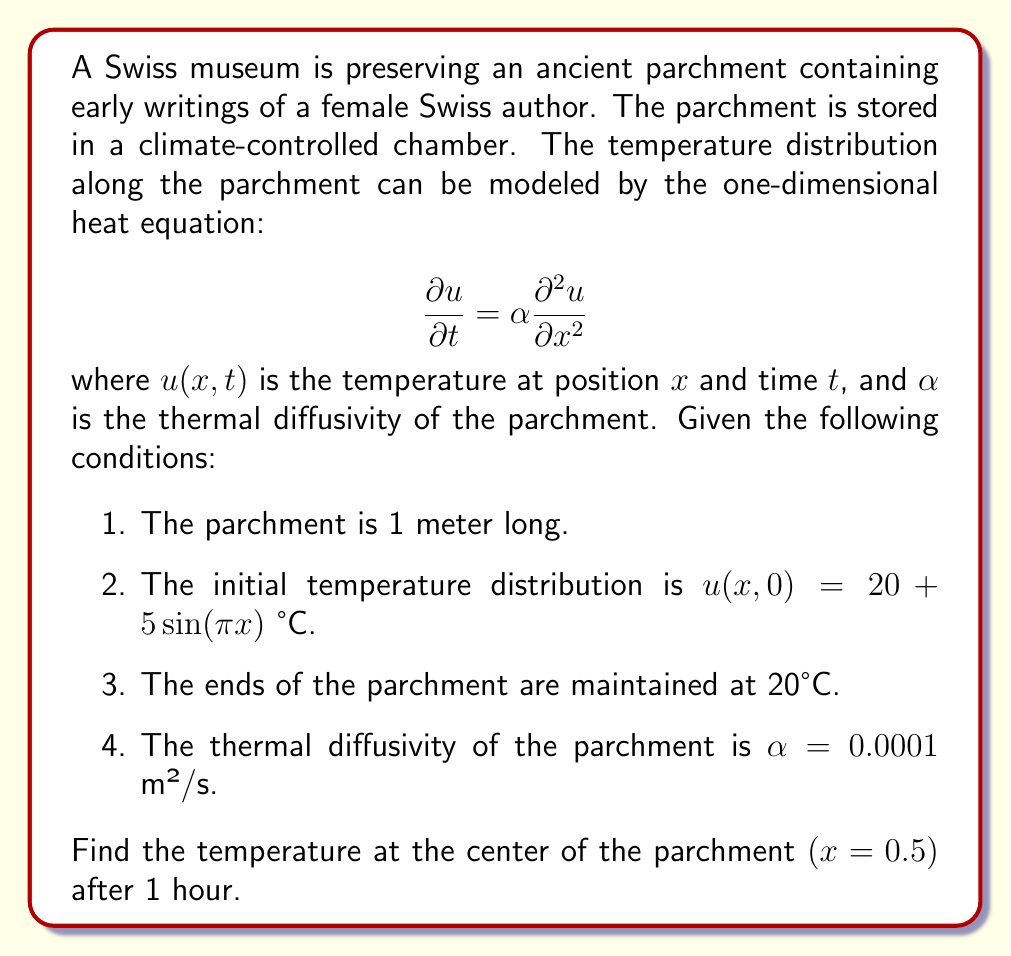Teach me how to tackle this problem. To solve this problem, we'll use the method of separation of variables for the heat equation.

Step 1: The general solution to the heat equation with the given boundary conditions is:

$$u(x,t) = 20 + \sum_{n=1}^{\infty} B_n \sin(n\pi x) e^{-\alpha n^2\pi^2 t}$$

Step 2: Given the initial condition, we only need to consider $n=1$:

$$u(x,0) = 20 + 5\sin(\pi x)$$

So, $B_1 = 5$ and $B_n = 0$ for $n > 1$.

Step 3: Our solution simplifies to:

$$u(x,t) = 20 + 5\sin(\pi x) e^{-\alpha \pi^2 t}$$

Step 4: Calculate the temperature at $x = 0.5$ and $t = 3600$ seconds (1 hour):

$$u(0.5, 3600) = 20 + 5\sin(\pi \cdot 0.5) e^{-0.0001 \cdot \pi^2 \cdot 3600}$$

Step 5: Evaluate:
- $\sin(\pi \cdot 0.5) = 1$
- $e^{-0.0001 \cdot \pi^2 \cdot 3600} \approx 0.0306$

Step 6: Calculate the final temperature:

$$u(0.5, 3600) = 20 + 5 \cdot 1 \cdot 0.0306 \approx 20.153 \text{ °C}$$
Answer: 20.153 °C 